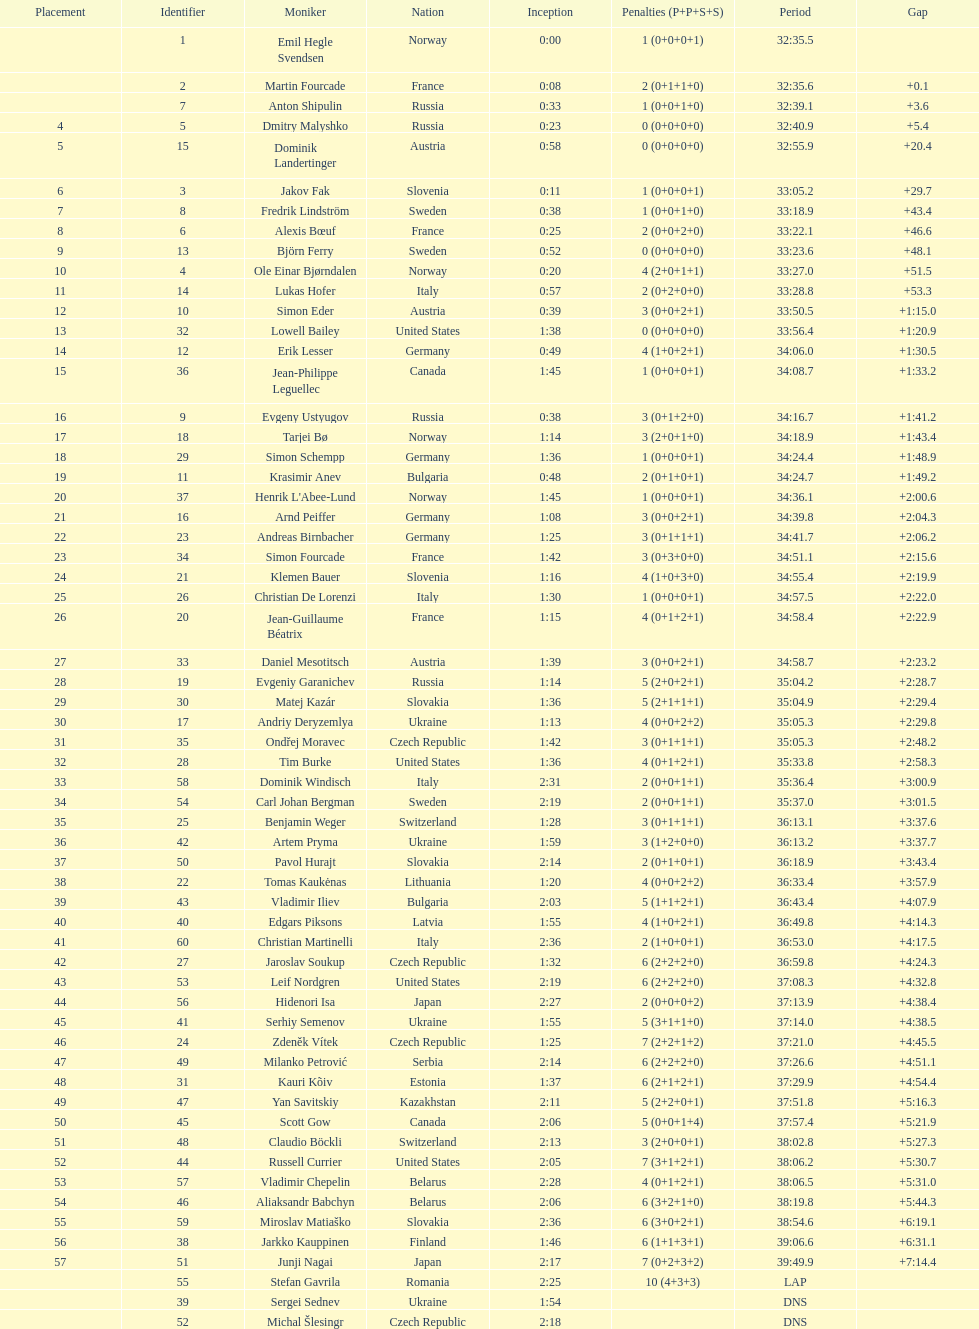What is the largest penalty? 10. 